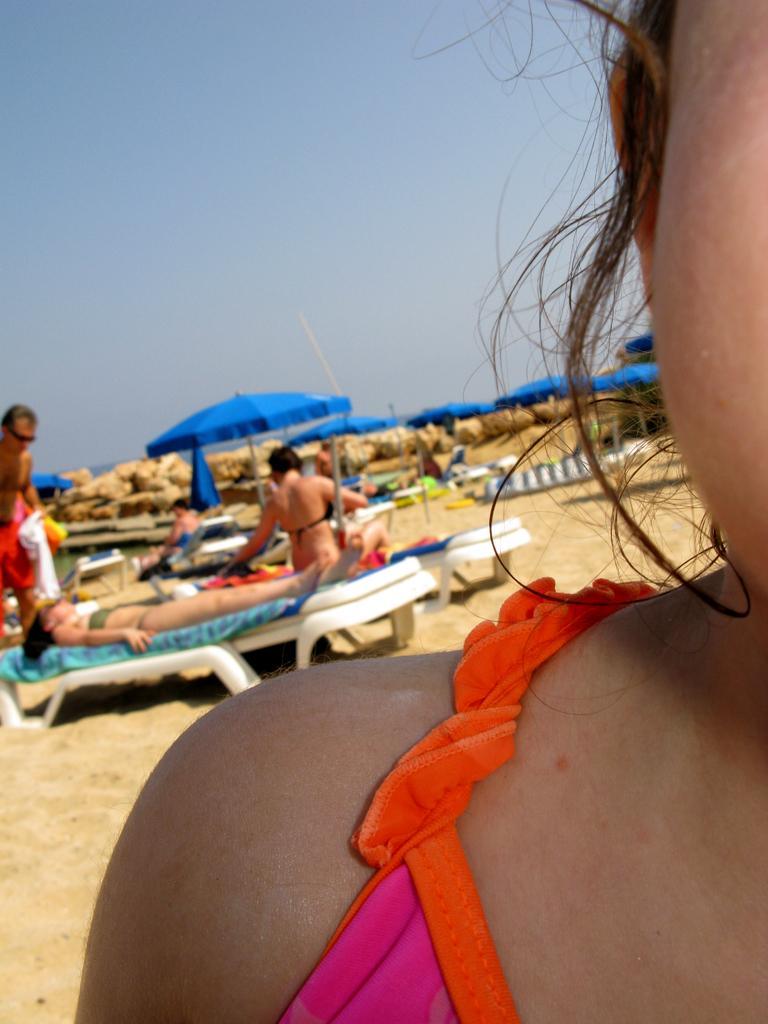How would you summarize this image in a sentence or two? In this image it looks like it is a beach in which there are few people sleeping on the beds. In the background there are blue coloured umbrellas under which there are few people sleeping on the beds. At the top there is sky. On the right side there is a woman. Behind the umbrellas there are stones. 